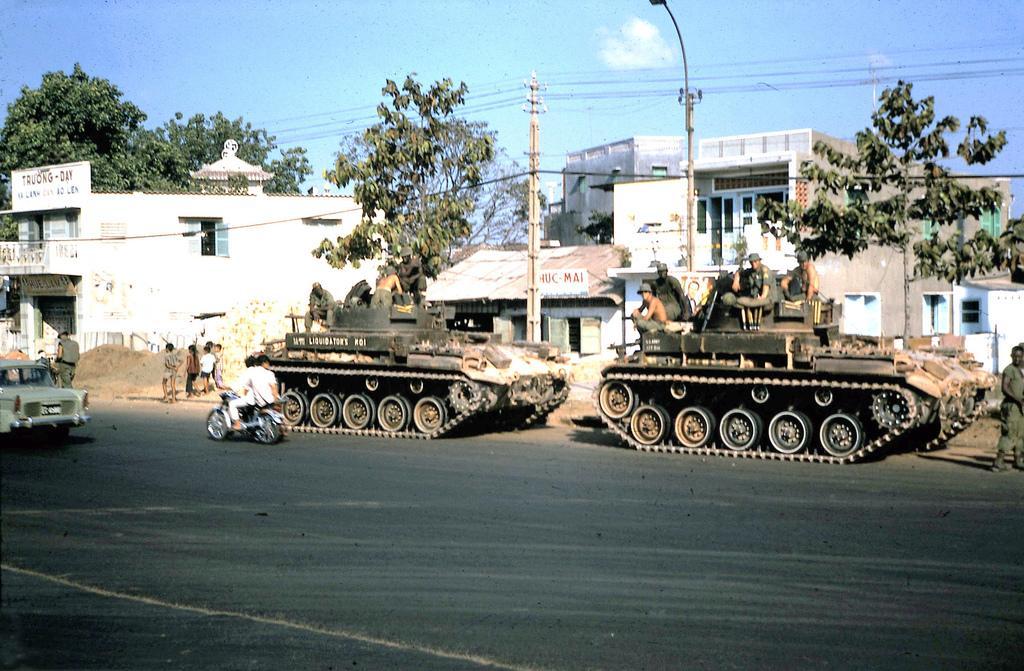How would you summarize this image in a sentence or two? In the picture we can see a road on it, we can see a motorcycle with two people are sitting and riding it and in front of them, we can also see a car and besides, we can see two army tankers with some army people sitting on the top of it and besides it, we can see some poles with wires and trees and behind it we can see some houses, buildings and to it we can see some doors and windows and in the background we can see a sky with clouds. 